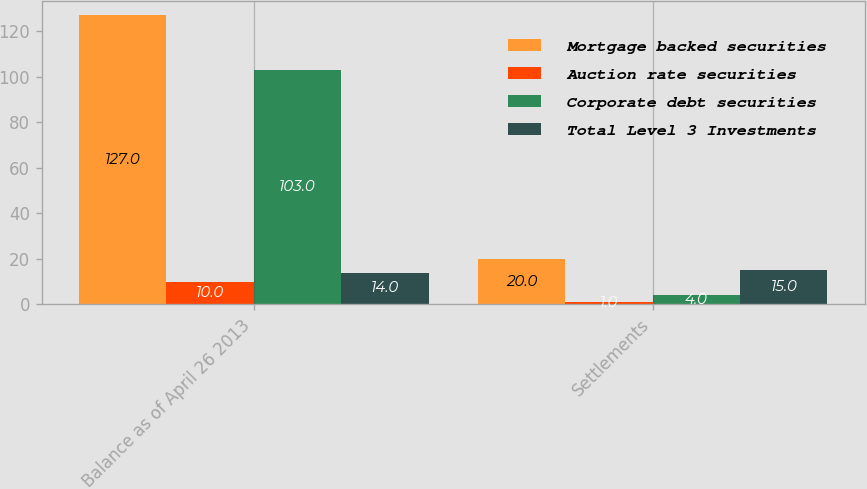Convert chart to OTSL. <chart><loc_0><loc_0><loc_500><loc_500><stacked_bar_chart><ecel><fcel>Balance as of April 26 2013<fcel>Settlements<nl><fcel>Mortgage backed securities<fcel>127<fcel>20<nl><fcel>Auction rate securities<fcel>10<fcel>1<nl><fcel>Corporate debt securities<fcel>103<fcel>4<nl><fcel>Total Level 3 Investments<fcel>14<fcel>15<nl></chart> 